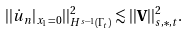<formula> <loc_0><loc_0><loc_500><loc_500>| | \dot { u } _ { n } | _ { x _ { 1 } = 0 } | | ^ { 2 } _ { H ^ { s - 1 } ( \Gamma _ { t } ) } \lesssim | | { \mathbf V } | | ^ { 2 } _ { s , \ast , t } .</formula> 